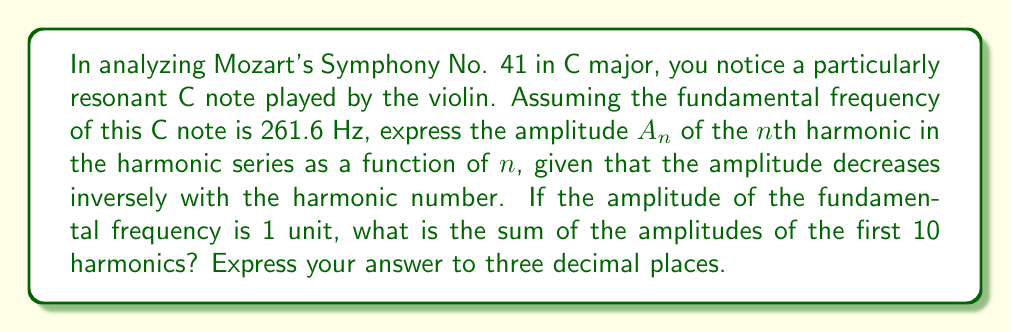Show me your answer to this math problem. To solve this problem, we'll follow these steps:

1) First, let's express the amplitude $A_n$ of the nth harmonic:
   
   $A_n = \frac{1}{n}$, where n is the harmonic number

2) Now, we need to find the sum of the amplitudes of the first 10 harmonics:

   $S = \sum_{n=1}^{10} A_n = \sum_{n=1}^{10} \frac{1}{n}$

3) This is a partial sum of the harmonic series. We can calculate it directly:

   $S = 1 + \frac{1}{2} + \frac{1}{3} + \frac{1}{4} + \frac{1}{5} + \frac{1}{6} + \frac{1}{7} + \frac{1}{8} + \frac{1}{9} + \frac{1}{10}$

4) Using a calculator or computer to sum these terms:

   $S ≈ 2.9289682539682539...$

5) Rounding to three decimal places:

   $S ≈ 2.929$

This sum represents the total relative amplitude of the first 10 harmonics in the C note from Mozart's symphony, assuming the fundamental has an amplitude of 1 unit and the amplitudes decrease inversely with the harmonic number.
Answer: 2.929 